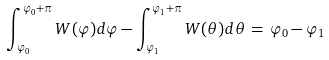<formula> <loc_0><loc_0><loc_500><loc_500>\int _ { \varphi _ { 0 } } ^ { \varphi _ { 0 } + \pi } W ( \varphi ) d \varphi - \int _ { \varphi _ { 1 } } ^ { \varphi _ { 1 } + \pi } W ( \theta ) d \theta \, = \, \varphi _ { 0 } - \varphi _ { 1 }</formula> 